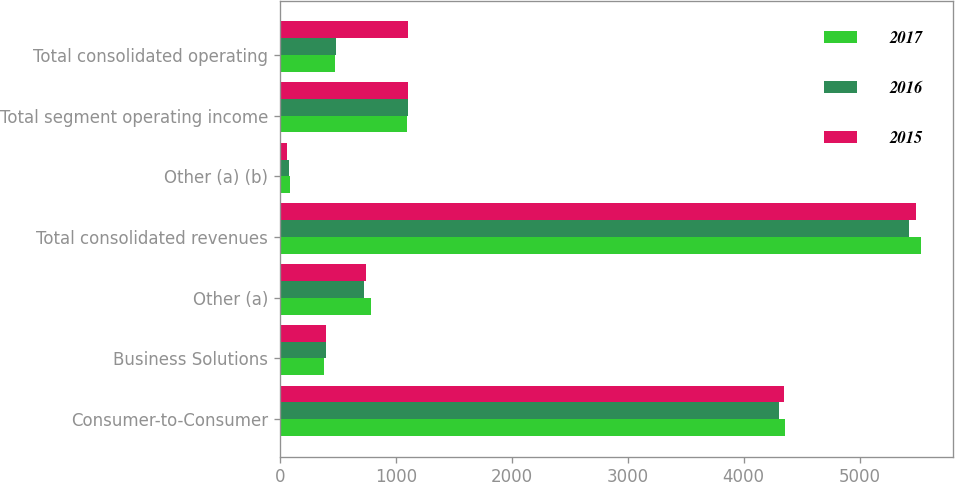Convert chart. <chart><loc_0><loc_0><loc_500><loc_500><stacked_bar_chart><ecel><fcel>Consumer-to-Consumer<fcel>Business Solutions<fcel>Other (a)<fcel>Total consolidated revenues<fcel>Other (a) (b)<fcel>Total segment operating income<fcel>Total consolidated operating<nl><fcel>2017<fcel>4354.5<fcel>383.9<fcel>785.9<fcel>5524.3<fcel>83.8<fcel>1099.8<fcel>473.4<nl><fcel>2016<fcel>4304.6<fcel>396<fcel>722.3<fcel>5422.9<fcel>75.2<fcel>1105<fcel>483.7<nl><fcel>2015<fcel>4343.9<fcel>398.7<fcel>741.1<fcel>5483.7<fcel>64.6<fcel>1109.4<fcel>1109.4<nl></chart> 